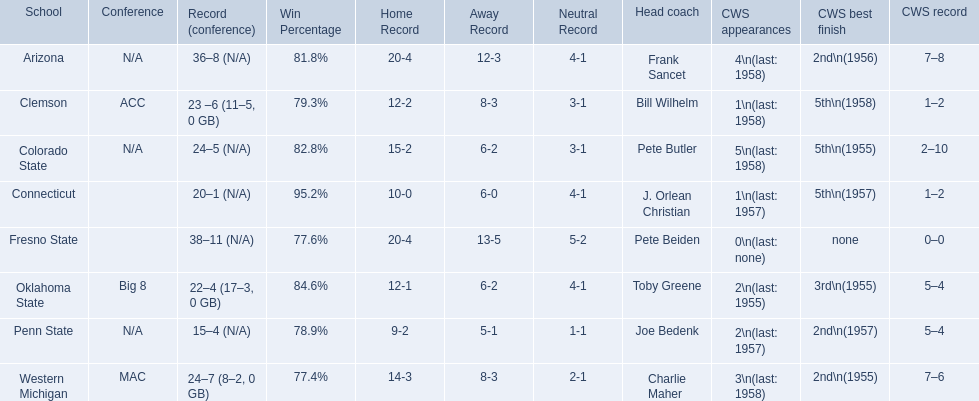What are the listed schools? Arizona, Clemson, Colorado State, Connecticut, Fresno State, Oklahoma State, Penn State, Western Michigan. Which are clemson and western michigan? Clemson, Western Michigan. What are their corresponding numbers of cws appearances? 1\n(last: 1958), 3\n(last: 1958). Which value is larger? 3\n(last: 1958). To which school does that value belong to? Western Michigan. 